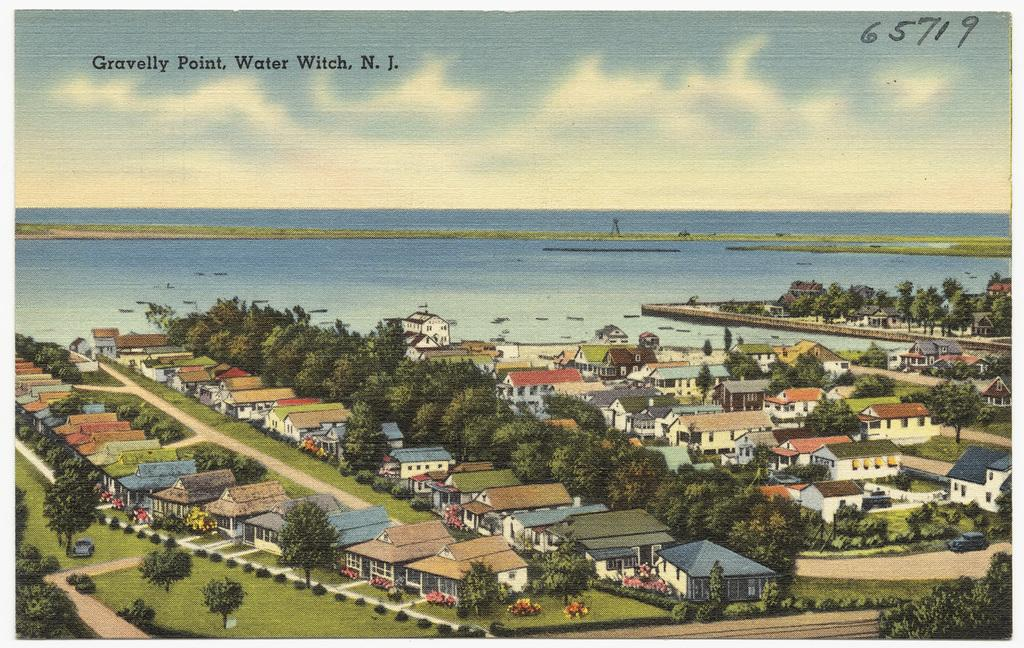What is the main subject of the poster in the image? The poster contains images of trees, houses, and grass. What type of natural environment is depicted on the poster? The poster contains images of trees, grass, and a lake, which suggests a natural environment. What is visible behind the poster in the image? There is a lake visible behind the poster. How many children are playing in the basin in the image? There are no children or basin present in the image. 